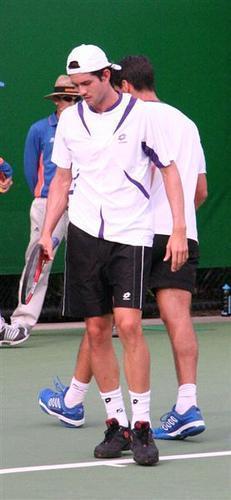How many people are in the photo?
Give a very brief answer. 3. How many horses are pulling the plow?
Give a very brief answer. 0. 